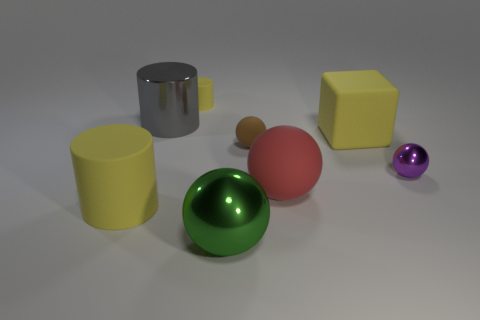Subtract 1 cylinders. How many cylinders are left? 2 Subtract all blue spheres. Subtract all purple blocks. How many spheres are left? 4 Add 2 large gray metal cylinders. How many objects exist? 10 Subtract all blocks. How many objects are left? 7 Subtract all cylinders. Subtract all brown rubber objects. How many objects are left? 4 Add 7 tiny yellow rubber cylinders. How many tiny yellow rubber cylinders are left? 8 Add 1 purple metallic objects. How many purple metallic objects exist? 2 Subtract 1 green balls. How many objects are left? 7 